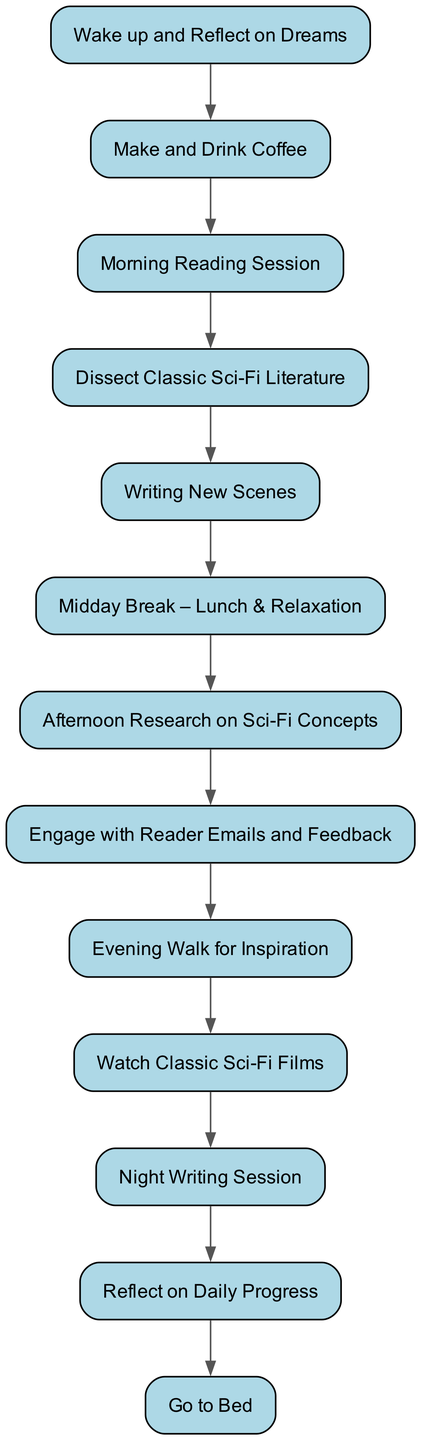What is the first activity in the daily routine? The first activity in the diagram is represented by the node with id "1" which is "Wake up and Reflect on Dreams."
Answer: Wake up and Reflect on Dreams How many activities are there in total? Counting all the nodes listed in the activities section, there are twelve unique activities.
Answer: 12 What is the last activity before going to bed? The last activity before "Go to Bed" is represented by the node with id "12," which is "Reflect on Daily Progress."
Answer: Reflect on Daily Progress What is the activity following "Afternoon Research on Sci-Fi Concepts"? The activity that directly follows "Afternoon Research on Sci-Fi Concepts" is represented by id "8," which is "Engage with Reader Emails and Feedback."
Answer: Engage with Reader Emails and Feedback How many edges connect the activities? There are eleven edges connecting the activities, as indicated by the transitions section which specifies the flow from one activity to the next.
Answer: 11 What activity takes place after drinking coffee? The activity that follows "Make and Drink Coffee" is the third step, represented by id "3," which is "Morning Reading Session."
Answer: Morning Reading Session Is there a transition between "Watch Classic Sci-Fi Films" and "Night Writing Session"? Yes, there is a direct transition from "Watch Classic Sci-Fi Films" (id "10") to "Night Writing Session" (id "11").
Answer: Yes Which two activities are connected by the edge from "Writing New Scenes"? The edge from "Writing New Scenes" (id "5") leads to "Midday Break – Lunch & Relaxation" (id "6").
Answer: Midday Break – Lunch & Relaxation What is the sequence of activities from waking up to lunch? The sequence is: "Wake up and Reflect on Dreams" → "Make and Drink Coffee" → "Morning Reading Session" → "Dissect Classic Sci-Fi Literature" → "Writing New Scenes" → "Midday Break – Lunch & Relaxation."
Answer: Wake up and Reflect on Dreams, Make and Drink Coffee, Morning Reading Session, Dissect Classic Sci-Fi Literature, Writing New Scenes, Midday Break – Lunch & Relaxation 